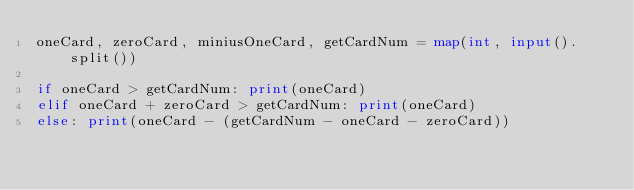Convert code to text. <code><loc_0><loc_0><loc_500><loc_500><_Python_>oneCard, zeroCard, miniusOneCard, getCardNum = map(int, input().split())

if oneCard > getCardNum: print(oneCard)
elif oneCard + zeroCard > getCardNum: print(oneCard)
else: print(oneCard - (getCardNum - oneCard - zeroCard))</code> 